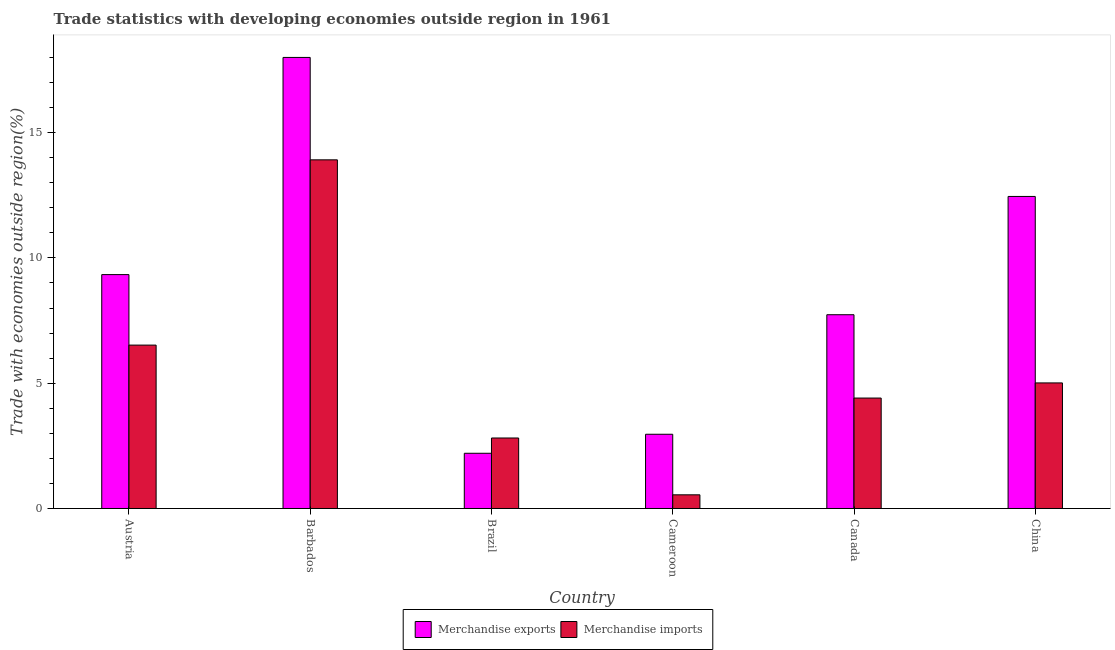Are the number of bars per tick equal to the number of legend labels?
Your response must be concise. Yes. Are the number of bars on each tick of the X-axis equal?
Provide a succinct answer. Yes. How many bars are there on the 2nd tick from the left?
Offer a very short reply. 2. What is the label of the 2nd group of bars from the left?
Offer a terse response. Barbados. What is the merchandise exports in Cameroon?
Give a very brief answer. 2.96. Across all countries, what is the minimum merchandise imports?
Make the answer very short. 0.55. In which country was the merchandise imports maximum?
Provide a short and direct response. Barbados. In which country was the merchandise imports minimum?
Your answer should be very brief. Cameroon. What is the total merchandise exports in the graph?
Provide a short and direct response. 52.68. What is the difference between the merchandise exports in Barbados and that in China?
Provide a short and direct response. 5.55. What is the difference between the merchandise imports in Brazil and the merchandise exports in Barbados?
Offer a terse response. -15.19. What is the average merchandise exports per country?
Make the answer very short. 8.78. What is the difference between the merchandise exports and merchandise imports in Barbados?
Keep it short and to the point. 4.09. What is the ratio of the merchandise exports in Barbados to that in Brazil?
Keep it short and to the point. 8.17. What is the difference between the highest and the second highest merchandise imports?
Make the answer very short. 7.39. What is the difference between the highest and the lowest merchandise exports?
Keep it short and to the point. 15.8. In how many countries, is the merchandise exports greater than the average merchandise exports taken over all countries?
Your answer should be compact. 3. What does the 2nd bar from the left in China represents?
Provide a short and direct response. Merchandise imports. What does the 2nd bar from the right in Austria represents?
Give a very brief answer. Merchandise exports. How many bars are there?
Offer a terse response. 12. Are all the bars in the graph horizontal?
Offer a terse response. No. How many countries are there in the graph?
Your answer should be very brief. 6. What is the difference between two consecutive major ticks on the Y-axis?
Offer a very short reply. 5. Are the values on the major ticks of Y-axis written in scientific E-notation?
Provide a succinct answer. No. Does the graph contain any zero values?
Your response must be concise. No. Where does the legend appear in the graph?
Make the answer very short. Bottom center. What is the title of the graph?
Your response must be concise. Trade statistics with developing economies outside region in 1961. Does "Time to export" appear as one of the legend labels in the graph?
Provide a succinct answer. No. What is the label or title of the X-axis?
Give a very brief answer. Country. What is the label or title of the Y-axis?
Your answer should be compact. Trade with economies outside region(%). What is the Trade with economies outside region(%) of Merchandise exports in Austria?
Offer a terse response. 9.33. What is the Trade with economies outside region(%) in Merchandise imports in Austria?
Offer a very short reply. 6.52. What is the Trade with economies outside region(%) in Merchandise imports in Barbados?
Ensure brevity in your answer.  13.91. What is the Trade with economies outside region(%) of Merchandise exports in Brazil?
Provide a short and direct response. 2.2. What is the Trade with economies outside region(%) in Merchandise imports in Brazil?
Give a very brief answer. 2.81. What is the Trade with economies outside region(%) of Merchandise exports in Cameroon?
Provide a succinct answer. 2.96. What is the Trade with economies outside region(%) of Merchandise imports in Cameroon?
Your response must be concise. 0.55. What is the Trade with economies outside region(%) in Merchandise exports in Canada?
Give a very brief answer. 7.73. What is the Trade with economies outside region(%) in Merchandise imports in Canada?
Your response must be concise. 4.41. What is the Trade with economies outside region(%) of Merchandise exports in China?
Your answer should be very brief. 12.45. What is the Trade with economies outside region(%) in Merchandise imports in China?
Provide a succinct answer. 5.01. Across all countries, what is the maximum Trade with economies outside region(%) in Merchandise exports?
Your response must be concise. 18. Across all countries, what is the maximum Trade with economies outside region(%) of Merchandise imports?
Your answer should be very brief. 13.91. Across all countries, what is the minimum Trade with economies outside region(%) in Merchandise exports?
Offer a very short reply. 2.2. Across all countries, what is the minimum Trade with economies outside region(%) in Merchandise imports?
Your answer should be very brief. 0.55. What is the total Trade with economies outside region(%) in Merchandise exports in the graph?
Your answer should be compact. 52.68. What is the total Trade with economies outside region(%) in Merchandise imports in the graph?
Offer a terse response. 33.21. What is the difference between the Trade with economies outside region(%) of Merchandise exports in Austria and that in Barbados?
Ensure brevity in your answer.  -8.67. What is the difference between the Trade with economies outside region(%) in Merchandise imports in Austria and that in Barbados?
Your response must be concise. -7.39. What is the difference between the Trade with economies outside region(%) of Merchandise exports in Austria and that in Brazil?
Your answer should be very brief. 7.13. What is the difference between the Trade with economies outside region(%) of Merchandise imports in Austria and that in Brazil?
Give a very brief answer. 3.71. What is the difference between the Trade with economies outside region(%) of Merchandise exports in Austria and that in Cameroon?
Offer a very short reply. 6.37. What is the difference between the Trade with economies outside region(%) of Merchandise imports in Austria and that in Cameroon?
Your response must be concise. 5.97. What is the difference between the Trade with economies outside region(%) of Merchandise exports in Austria and that in Canada?
Ensure brevity in your answer.  1.6. What is the difference between the Trade with economies outside region(%) in Merchandise imports in Austria and that in Canada?
Provide a succinct answer. 2.11. What is the difference between the Trade with economies outside region(%) in Merchandise exports in Austria and that in China?
Ensure brevity in your answer.  -3.12. What is the difference between the Trade with economies outside region(%) of Merchandise imports in Austria and that in China?
Provide a short and direct response. 1.51. What is the difference between the Trade with economies outside region(%) in Merchandise exports in Barbados and that in Brazil?
Make the answer very short. 15.8. What is the difference between the Trade with economies outside region(%) in Merchandise imports in Barbados and that in Brazil?
Provide a succinct answer. 11.1. What is the difference between the Trade with economies outside region(%) in Merchandise exports in Barbados and that in Cameroon?
Provide a short and direct response. 15.04. What is the difference between the Trade with economies outside region(%) in Merchandise imports in Barbados and that in Cameroon?
Your response must be concise. 13.37. What is the difference between the Trade with economies outside region(%) of Merchandise exports in Barbados and that in Canada?
Make the answer very short. 10.27. What is the difference between the Trade with economies outside region(%) of Merchandise imports in Barbados and that in Canada?
Your response must be concise. 9.51. What is the difference between the Trade with economies outside region(%) in Merchandise exports in Barbados and that in China?
Your answer should be very brief. 5.55. What is the difference between the Trade with economies outside region(%) of Merchandise imports in Barbados and that in China?
Provide a succinct answer. 8.9. What is the difference between the Trade with economies outside region(%) in Merchandise exports in Brazil and that in Cameroon?
Provide a short and direct response. -0.76. What is the difference between the Trade with economies outside region(%) in Merchandise imports in Brazil and that in Cameroon?
Make the answer very short. 2.27. What is the difference between the Trade with economies outside region(%) in Merchandise exports in Brazil and that in Canada?
Ensure brevity in your answer.  -5.53. What is the difference between the Trade with economies outside region(%) in Merchandise imports in Brazil and that in Canada?
Give a very brief answer. -1.59. What is the difference between the Trade with economies outside region(%) in Merchandise exports in Brazil and that in China?
Give a very brief answer. -10.25. What is the difference between the Trade with economies outside region(%) in Merchandise imports in Brazil and that in China?
Provide a short and direct response. -2.2. What is the difference between the Trade with economies outside region(%) of Merchandise exports in Cameroon and that in Canada?
Provide a succinct answer. -4.77. What is the difference between the Trade with economies outside region(%) in Merchandise imports in Cameroon and that in Canada?
Ensure brevity in your answer.  -3.86. What is the difference between the Trade with economies outside region(%) of Merchandise exports in Cameroon and that in China?
Give a very brief answer. -9.49. What is the difference between the Trade with economies outside region(%) in Merchandise imports in Cameroon and that in China?
Make the answer very short. -4.47. What is the difference between the Trade with economies outside region(%) of Merchandise exports in Canada and that in China?
Provide a succinct answer. -4.72. What is the difference between the Trade with economies outside region(%) in Merchandise imports in Canada and that in China?
Keep it short and to the point. -0.6. What is the difference between the Trade with economies outside region(%) of Merchandise exports in Austria and the Trade with economies outside region(%) of Merchandise imports in Barbados?
Offer a very short reply. -4.58. What is the difference between the Trade with economies outside region(%) in Merchandise exports in Austria and the Trade with economies outside region(%) in Merchandise imports in Brazil?
Your response must be concise. 6.52. What is the difference between the Trade with economies outside region(%) of Merchandise exports in Austria and the Trade with economies outside region(%) of Merchandise imports in Cameroon?
Make the answer very short. 8.79. What is the difference between the Trade with economies outside region(%) of Merchandise exports in Austria and the Trade with economies outside region(%) of Merchandise imports in Canada?
Provide a short and direct response. 4.93. What is the difference between the Trade with economies outside region(%) of Merchandise exports in Austria and the Trade with economies outside region(%) of Merchandise imports in China?
Provide a short and direct response. 4.32. What is the difference between the Trade with economies outside region(%) in Merchandise exports in Barbados and the Trade with economies outside region(%) in Merchandise imports in Brazil?
Keep it short and to the point. 15.19. What is the difference between the Trade with economies outside region(%) in Merchandise exports in Barbados and the Trade with economies outside region(%) in Merchandise imports in Cameroon?
Your answer should be very brief. 17.45. What is the difference between the Trade with economies outside region(%) in Merchandise exports in Barbados and the Trade with economies outside region(%) in Merchandise imports in Canada?
Your response must be concise. 13.59. What is the difference between the Trade with economies outside region(%) in Merchandise exports in Barbados and the Trade with economies outside region(%) in Merchandise imports in China?
Ensure brevity in your answer.  12.99. What is the difference between the Trade with economies outside region(%) in Merchandise exports in Brazil and the Trade with economies outside region(%) in Merchandise imports in Cameroon?
Make the answer very short. 1.66. What is the difference between the Trade with economies outside region(%) of Merchandise exports in Brazil and the Trade with economies outside region(%) of Merchandise imports in Canada?
Offer a very short reply. -2.2. What is the difference between the Trade with economies outside region(%) of Merchandise exports in Brazil and the Trade with economies outside region(%) of Merchandise imports in China?
Make the answer very short. -2.81. What is the difference between the Trade with economies outside region(%) of Merchandise exports in Cameroon and the Trade with economies outside region(%) of Merchandise imports in Canada?
Ensure brevity in your answer.  -1.44. What is the difference between the Trade with economies outside region(%) of Merchandise exports in Cameroon and the Trade with economies outside region(%) of Merchandise imports in China?
Make the answer very short. -2.05. What is the difference between the Trade with economies outside region(%) in Merchandise exports in Canada and the Trade with economies outside region(%) in Merchandise imports in China?
Your answer should be very brief. 2.72. What is the average Trade with economies outside region(%) in Merchandise exports per country?
Make the answer very short. 8.78. What is the average Trade with economies outside region(%) in Merchandise imports per country?
Offer a terse response. 5.53. What is the difference between the Trade with economies outside region(%) of Merchandise exports and Trade with economies outside region(%) of Merchandise imports in Austria?
Provide a succinct answer. 2.81. What is the difference between the Trade with economies outside region(%) of Merchandise exports and Trade with economies outside region(%) of Merchandise imports in Barbados?
Provide a short and direct response. 4.09. What is the difference between the Trade with economies outside region(%) of Merchandise exports and Trade with economies outside region(%) of Merchandise imports in Brazil?
Offer a terse response. -0.61. What is the difference between the Trade with economies outside region(%) in Merchandise exports and Trade with economies outside region(%) in Merchandise imports in Cameroon?
Keep it short and to the point. 2.42. What is the difference between the Trade with economies outside region(%) of Merchandise exports and Trade with economies outside region(%) of Merchandise imports in Canada?
Give a very brief answer. 3.33. What is the difference between the Trade with economies outside region(%) of Merchandise exports and Trade with economies outside region(%) of Merchandise imports in China?
Your answer should be compact. 7.44. What is the ratio of the Trade with economies outside region(%) in Merchandise exports in Austria to that in Barbados?
Offer a terse response. 0.52. What is the ratio of the Trade with economies outside region(%) in Merchandise imports in Austria to that in Barbados?
Provide a short and direct response. 0.47. What is the ratio of the Trade with economies outside region(%) of Merchandise exports in Austria to that in Brazil?
Your response must be concise. 4.24. What is the ratio of the Trade with economies outside region(%) of Merchandise imports in Austria to that in Brazil?
Provide a succinct answer. 2.32. What is the ratio of the Trade with economies outside region(%) of Merchandise exports in Austria to that in Cameroon?
Offer a terse response. 3.15. What is the ratio of the Trade with economies outside region(%) of Merchandise imports in Austria to that in Cameroon?
Ensure brevity in your answer.  11.95. What is the ratio of the Trade with economies outside region(%) in Merchandise exports in Austria to that in Canada?
Give a very brief answer. 1.21. What is the ratio of the Trade with economies outside region(%) of Merchandise imports in Austria to that in Canada?
Ensure brevity in your answer.  1.48. What is the ratio of the Trade with economies outside region(%) in Merchandise exports in Austria to that in China?
Offer a terse response. 0.75. What is the ratio of the Trade with economies outside region(%) of Merchandise imports in Austria to that in China?
Offer a very short reply. 1.3. What is the ratio of the Trade with economies outside region(%) in Merchandise exports in Barbados to that in Brazil?
Offer a terse response. 8.17. What is the ratio of the Trade with economies outside region(%) in Merchandise imports in Barbados to that in Brazil?
Keep it short and to the point. 4.95. What is the ratio of the Trade with economies outside region(%) of Merchandise exports in Barbados to that in Cameroon?
Offer a very short reply. 6.08. What is the ratio of the Trade with economies outside region(%) of Merchandise imports in Barbados to that in Cameroon?
Keep it short and to the point. 25.51. What is the ratio of the Trade with economies outside region(%) in Merchandise exports in Barbados to that in Canada?
Make the answer very short. 2.33. What is the ratio of the Trade with economies outside region(%) in Merchandise imports in Barbados to that in Canada?
Ensure brevity in your answer.  3.16. What is the ratio of the Trade with economies outside region(%) of Merchandise exports in Barbados to that in China?
Make the answer very short. 1.45. What is the ratio of the Trade with economies outside region(%) in Merchandise imports in Barbados to that in China?
Your response must be concise. 2.78. What is the ratio of the Trade with economies outside region(%) of Merchandise exports in Brazil to that in Cameroon?
Your response must be concise. 0.74. What is the ratio of the Trade with economies outside region(%) of Merchandise imports in Brazil to that in Cameroon?
Offer a very short reply. 5.16. What is the ratio of the Trade with economies outside region(%) in Merchandise exports in Brazil to that in Canada?
Ensure brevity in your answer.  0.28. What is the ratio of the Trade with economies outside region(%) of Merchandise imports in Brazil to that in Canada?
Ensure brevity in your answer.  0.64. What is the ratio of the Trade with economies outside region(%) of Merchandise exports in Brazil to that in China?
Your answer should be compact. 0.18. What is the ratio of the Trade with economies outside region(%) in Merchandise imports in Brazil to that in China?
Ensure brevity in your answer.  0.56. What is the ratio of the Trade with economies outside region(%) in Merchandise exports in Cameroon to that in Canada?
Provide a succinct answer. 0.38. What is the ratio of the Trade with economies outside region(%) of Merchandise imports in Cameroon to that in Canada?
Your answer should be compact. 0.12. What is the ratio of the Trade with economies outside region(%) of Merchandise exports in Cameroon to that in China?
Provide a succinct answer. 0.24. What is the ratio of the Trade with economies outside region(%) in Merchandise imports in Cameroon to that in China?
Make the answer very short. 0.11. What is the ratio of the Trade with economies outside region(%) in Merchandise exports in Canada to that in China?
Provide a short and direct response. 0.62. What is the ratio of the Trade with economies outside region(%) in Merchandise imports in Canada to that in China?
Offer a terse response. 0.88. What is the difference between the highest and the second highest Trade with economies outside region(%) in Merchandise exports?
Offer a very short reply. 5.55. What is the difference between the highest and the second highest Trade with economies outside region(%) of Merchandise imports?
Offer a very short reply. 7.39. What is the difference between the highest and the lowest Trade with economies outside region(%) in Merchandise exports?
Your response must be concise. 15.8. What is the difference between the highest and the lowest Trade with economies outside region(%) of Merchandise imports?
Offer a very short reply. 13.37. 